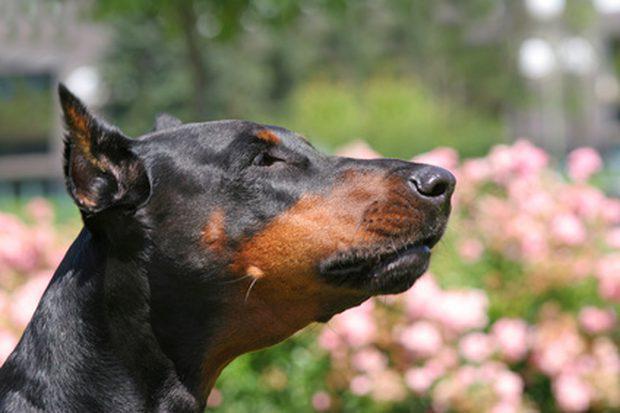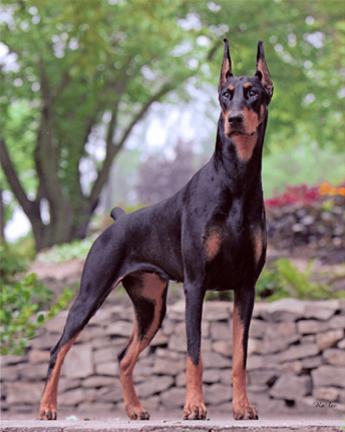The first image is the image on the left, the second image is the image on the right. Assess this claim about the two images: "At least one doberman has its tongue out.". Correct or not? Answer yes or no. No. The first image is the image on the left, the second image is the image on the right. Evaluate the accuracy of this statement regarding the images: "One image shows side-by-side dobermans with at least one having erect ears, and the other image shows one rightward-turned doberman with docked tail and erect pointy ears.". Is it true? Answer yes or no. No. 